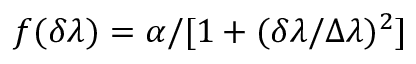Convert formula to latex. <formula><loc_0><loc_0><loc_500><loc_500>f ( \delta \lambda ) = \alpha / [ 1 + ( \delta \lambda / \Delta \lambda ) ^ { 2 } ]</formula> 